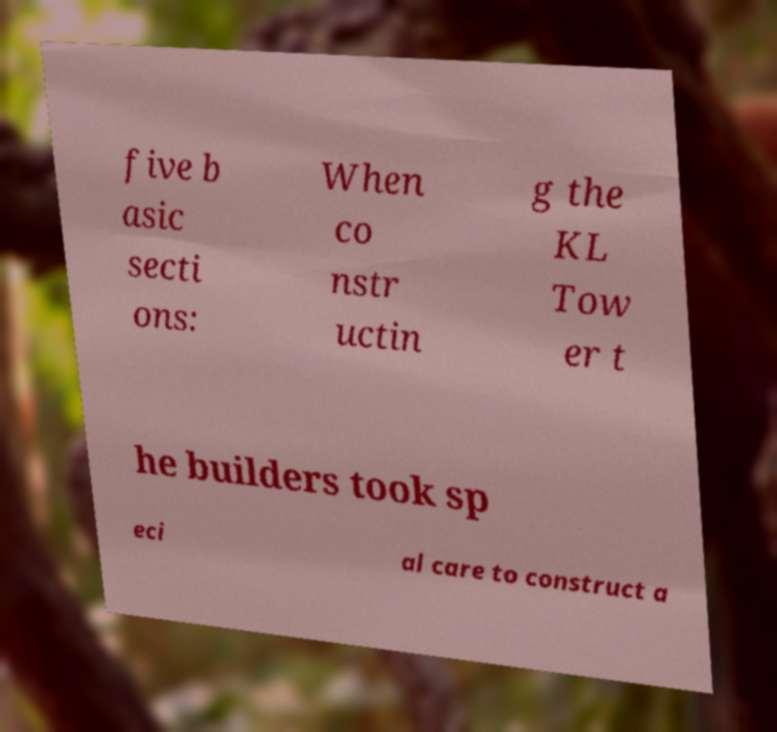Please read and relay the text visible in this image. What does it say? five b asic secti ons: When co nstr uctin g the KL Tow er t he builders took sp eci al care to construct a 